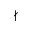Convert formula to latex. <formula><loc_0><loc_0><loc_500><loc_500>\nmid</formula> 